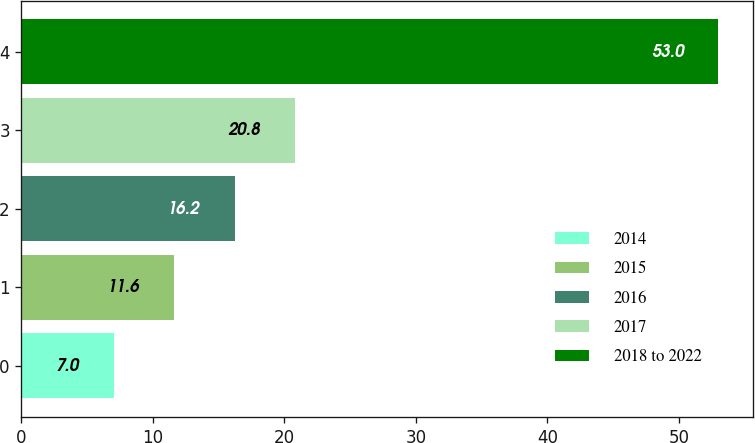Convert chart to OTSL. <chart><loc_0><loc_0><loc_500><loc_500><bar_chart><fcel>2014<fcel>2015<fcel>2016<fcel>2017<fcel>2018 to 2022<nl><fcel>7<fcel>11.6<fcel>16.2<fcel>20.8<fcel>53<nl></chart> 